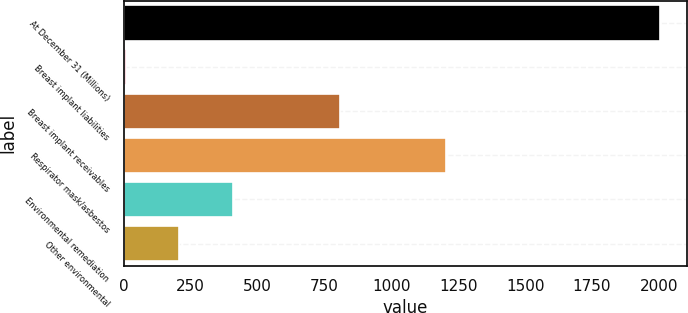Convert chart. <chart><loc_0><loc_0><loc_500><loc_500><bar_chart><fcel>At December 31 (Millions)<fcel>Breast implant liabilities<fcel>Breast implant receivables<fcel>Respirator mask/asbestos<fcel>Environmental remediation<fcel>Other environmental<nl><fcel>2005<fcel>7<fcel>806.2<fcel>1205.8<fcel>406.6<fcel>206.8<nl></chart> 